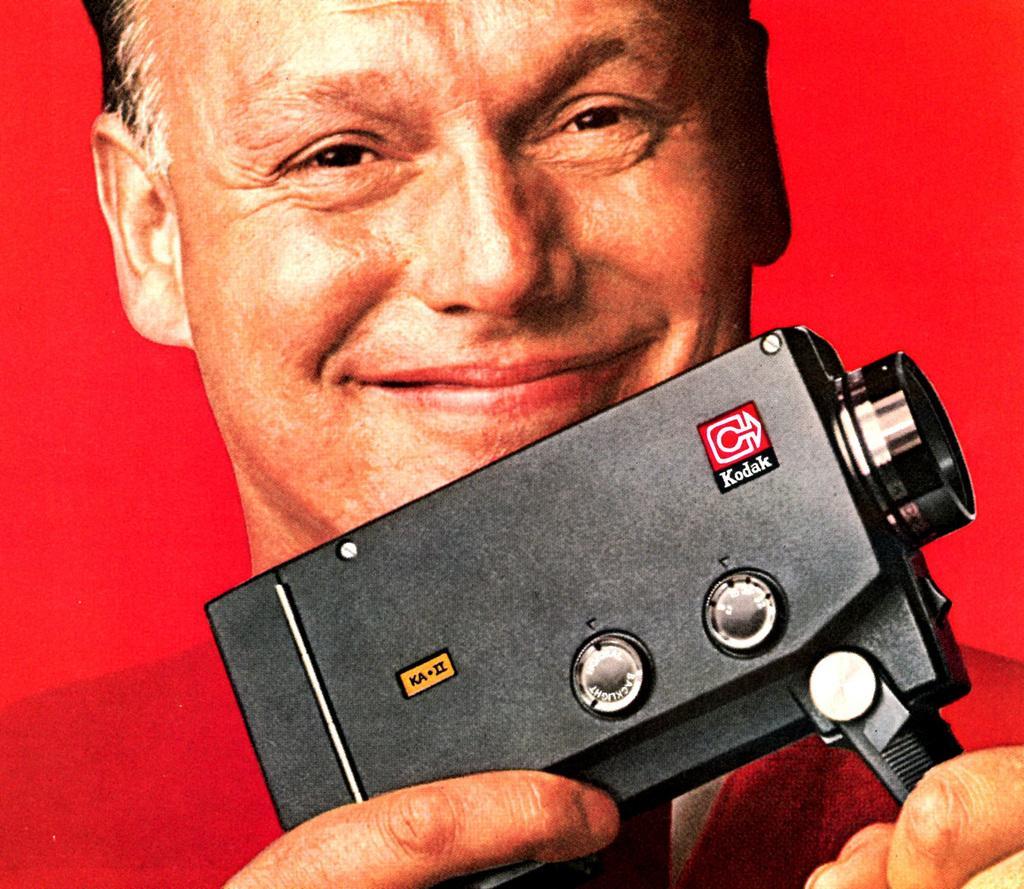Describe this image in one or two sentences. In this image the background is red in color. In the middle of the image there is a man with a smiling face and he is holding a camera in his hands. 